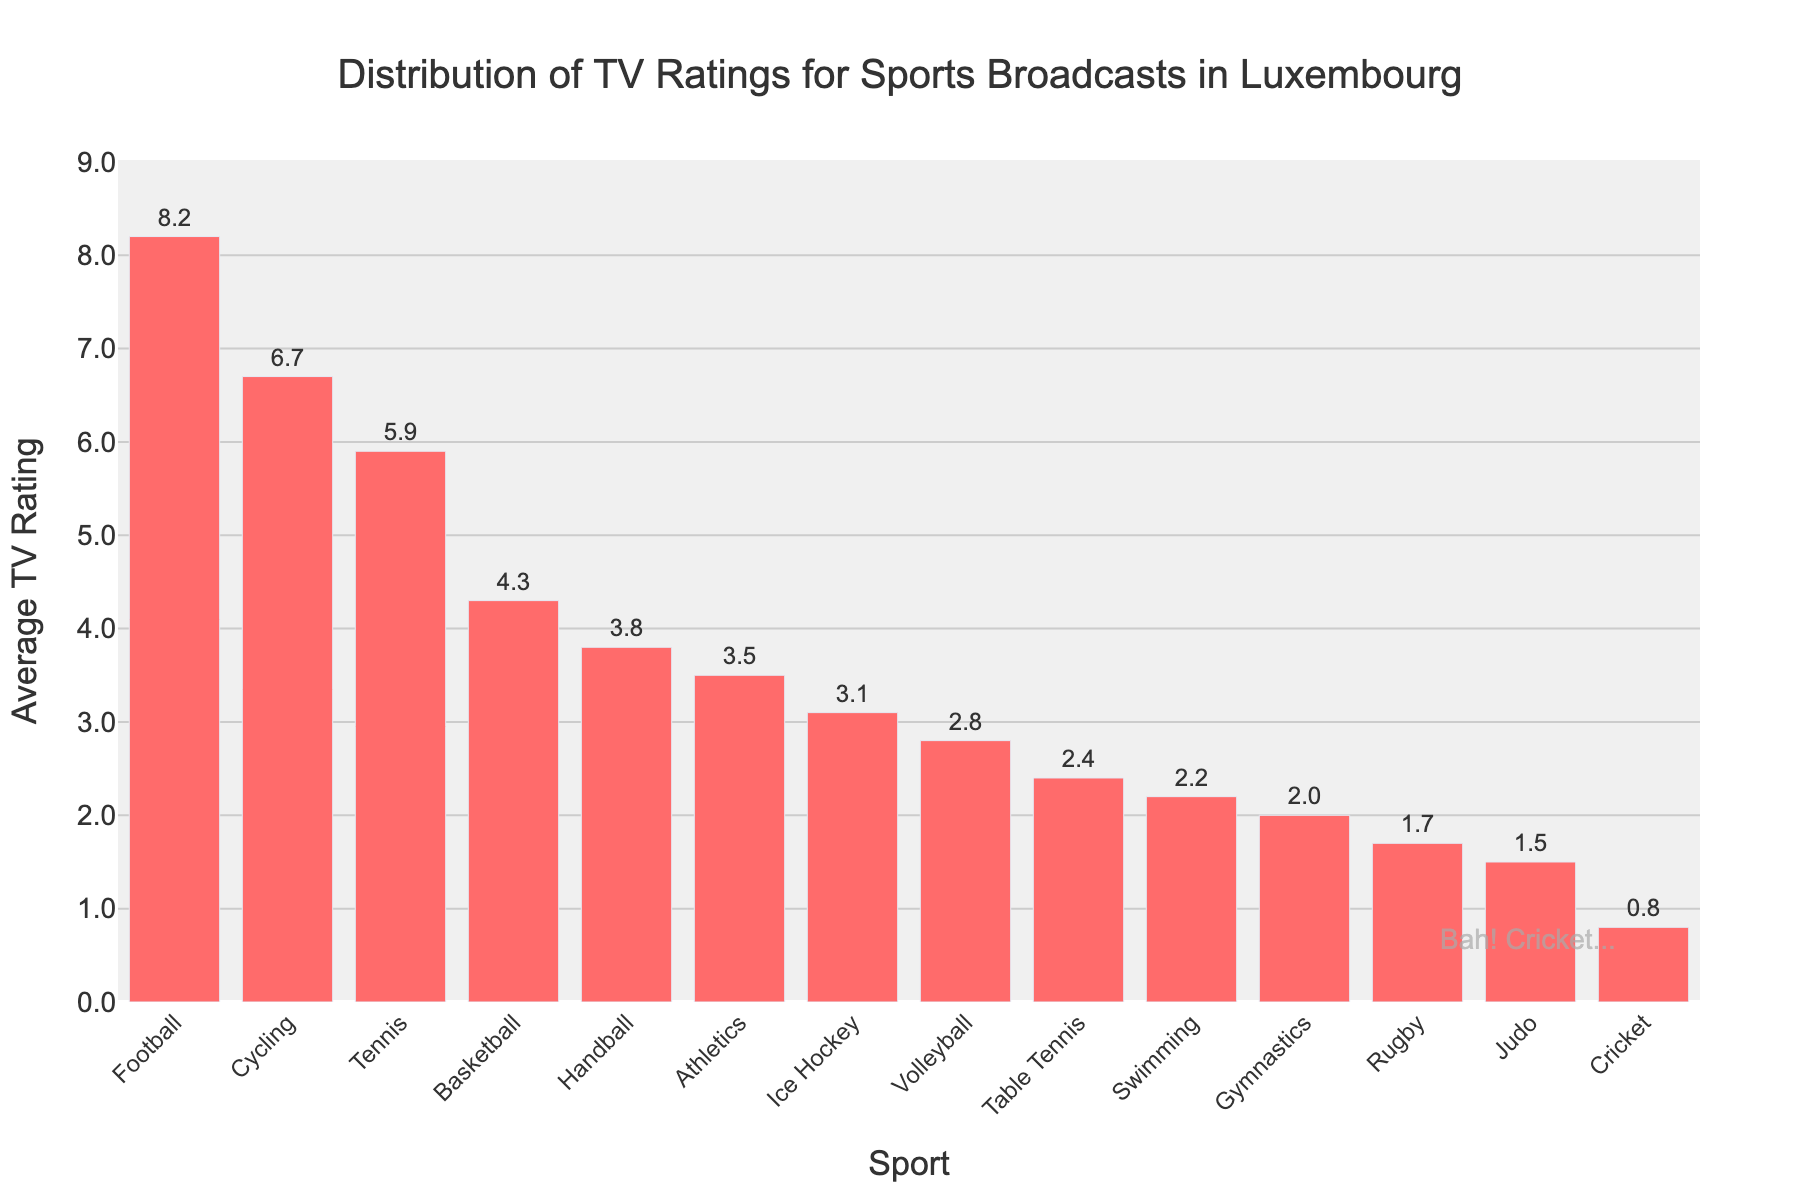What's the highest TV rating for the sports broadcasts in Luxembourg? The highest TV rating is represented by the tallest bar in the histogram. The title of the plot and the y-axis label indicate that it measures the TV ratings for different sports. By looking at the tallest bar, we see the corresponding sport and the height of the bar shows the rating.
Answer: 8.2 Which sport has the lowest TV rating and what is its value? The lowest TV rating is represented by the shortest bar in the histogram. Observing the shortest bar on the x-axis, we identify the sport and its corresponding rating on the y-axis.
Answer: Cricket, 0.8 What is the total TV rating if we combine Football and Cycling? To find the combined TV rating, we add the ratings of Football and Cycling. From the histogram, Football has a rating of 8.2 and Cycling has a rating of 6.7. Adding these two, 8.2 + 6.7, gives the combined rating.
Answer: 14.9 How does the TV rating for Tennis compare to Basketball? To compare them, we look at the heights of the bars for Tennis and Basketball. The plot shows Tennis has a height corresponding to 5.9 and Basketball to 4.3, indicating Tennis has a higher TV rating than Basketball.
Answer: Tennis has a higher rating than Basketball Which sport has a TV rating exactly twice that of Table Tennis? Table Tennis has a TV rating of 2.4. To find the sport with double this rating, we multiply 2.4 by 2, giving 4.8. Checking the histogram, we look for the bar with a height closest to 4.8 and see that none exactly matches, confirming no sport has precisely double the rating of Table Tennis.
Answer: None What's the average TV rating of the top three sports in the histogram? The top three sports are Football, Cycling, and Tennis with ratings of 8.2, 6.7, and 5.9 respectively. To find the average, we sum these ratings, 8.2 + 6.7 + 5.9 = 20.8, and then divide by 3. The average is 20.8 / 3.
Answer: 6.93 Which sports have TV ratings below the overall median TV rating? First, we list the TV ratings in ascending order and find the median value, which is the middle value in an ordered list of n values. With 14 data points, the median is the average of the 7th and 8th values. Ordering the ratings: 0.8, 1.5, 1.7, 2.0, 2.2, 2.4, 2.8, 3.1, 3.5, 3.8, 4.3, 5.9, 6.7, 8.2. The median is (2.8 + 3.1)/2 = 2.95. Sports below this median are those with ratings below 2.95.
Answer: Cricket, Judo, Rugby, Gymnastics, Swimming, Table Tennis, Volleyball What's the difference in TV ratings between Ice Hockey and Gymnastics? The histogram shows the TV ratings for Ice Hockey and Gymnastics as 3.1 and 2.0 respectively. Subtracting the smaller rating from the larger one, we find the difference, 3.1 - 2.0.
Answer: 1.1 How many sports have TV ratings above 4.0? Observing the bars that exceed the 4.0 mark on the y-axis, we count the number of sports.
Answer: 4 Which sport has roughly half the TV rating of Football? Football has a rating of 8.2. Half of 8.2 is 4.1. Checking the histogram, we see Handball has a rating closest to 4.1, aligning with the requirement.
Answer: Handball 